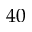<formula> <loc_0><loc_0><loc_500><loc_500>4 0</formula> 